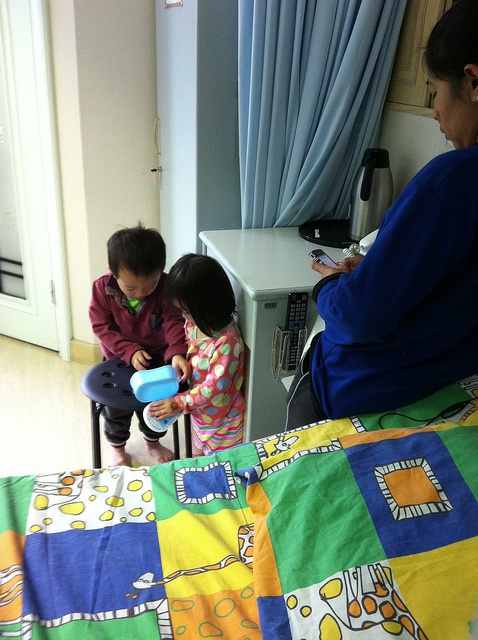Describe the objects in this image and their specific colors. I can see bed in beige, white, khaki, navy, and olive tones, people in beige, black, navy, and maroon tones, people in beige, black, maroon, brown, and gray tones, people in beige, black, maroon, brown, and gray tones, and chair in beige, black, gray, and lavender tones in this image. 